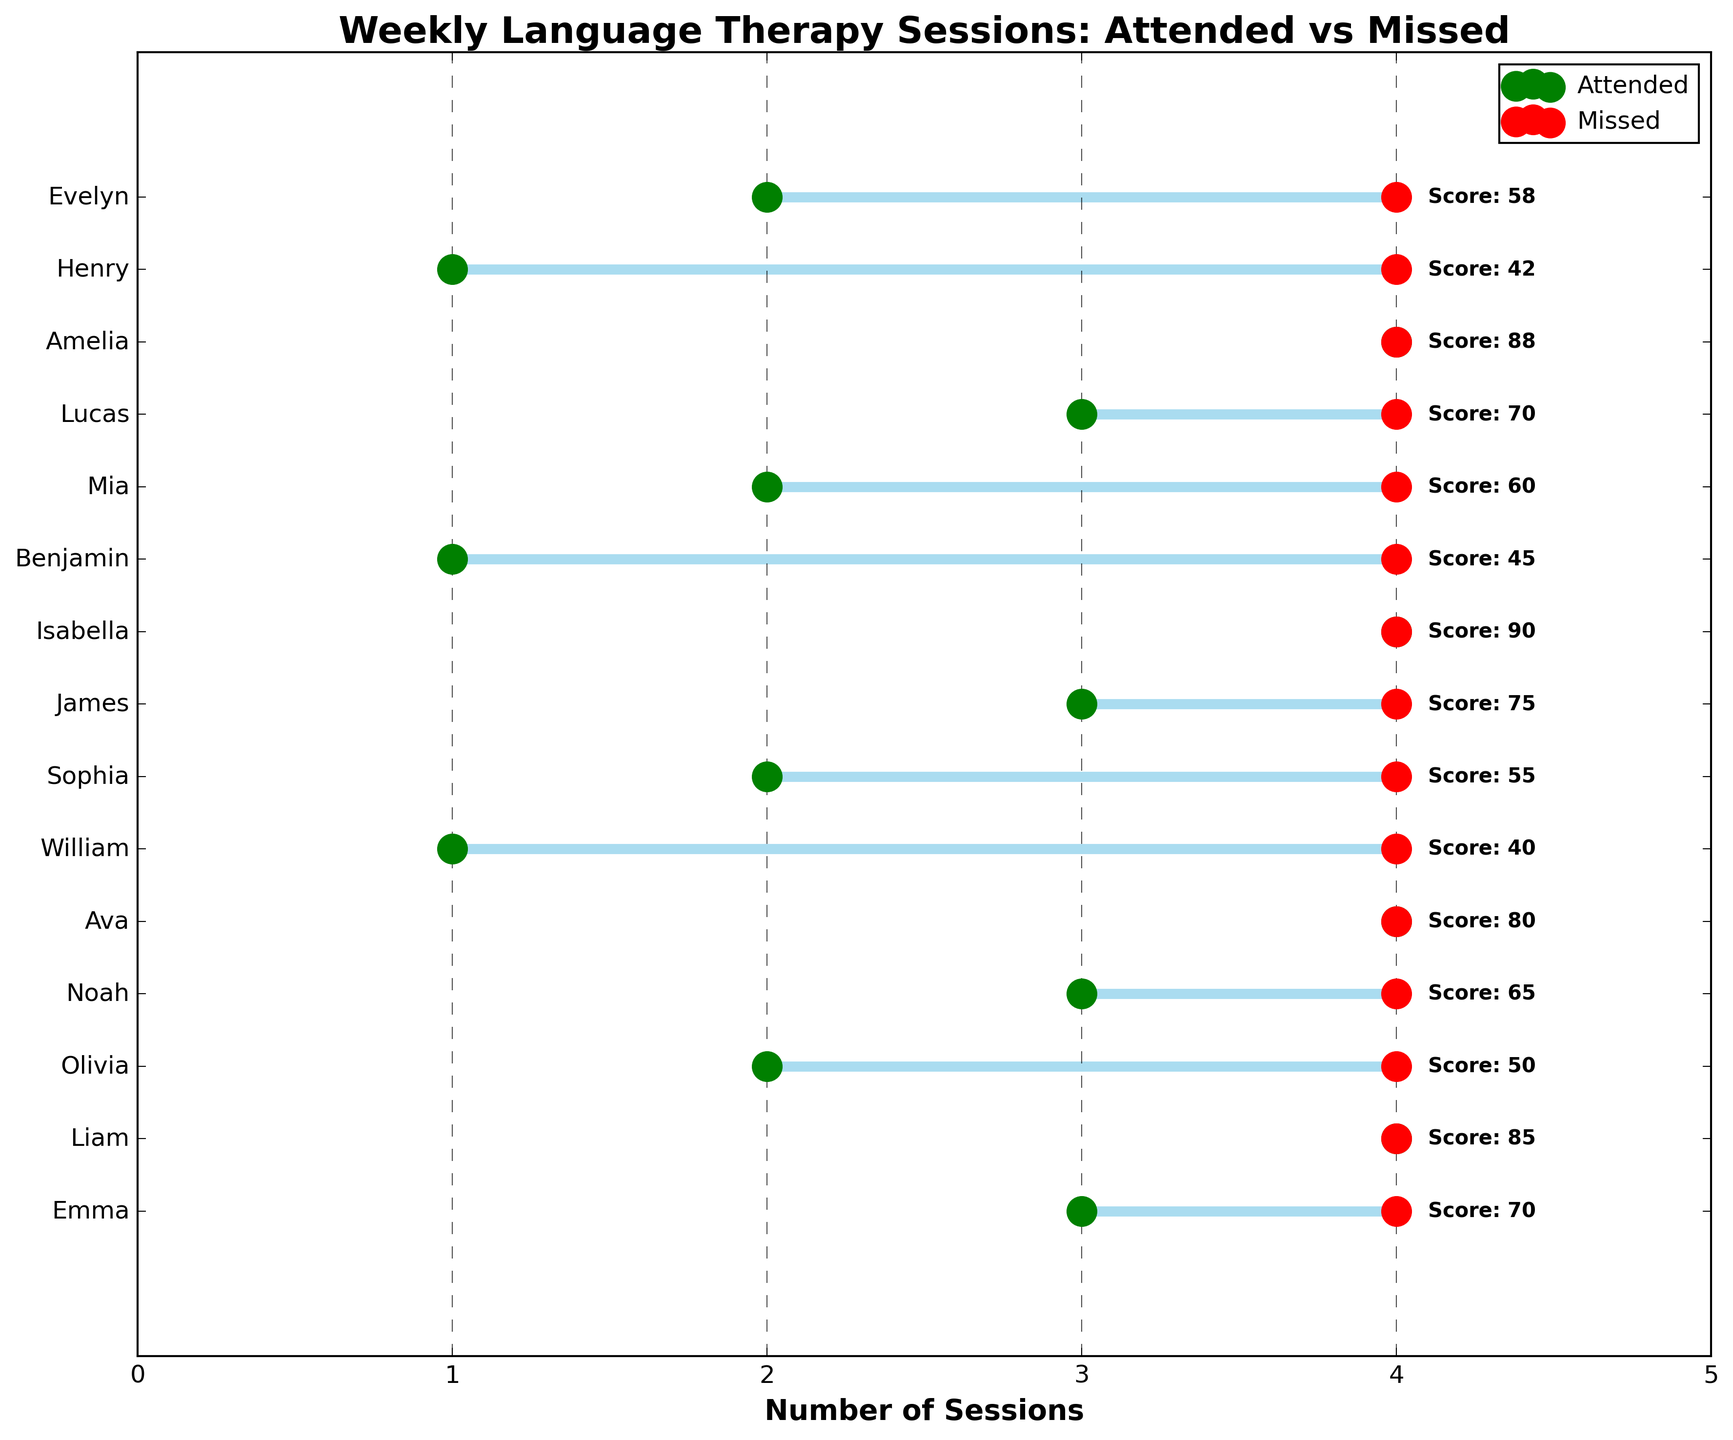What is the title of the figure? The title of the figure is usually located at the top and describes what the plot is about.
Answer: Weekly Language Therapy Sessions: Attended vs Missed How many sessions did Liam attend weekly? Liam's attended sessions can be found by looking at the green dot in his row.
Answer: 4 Whose progress score is the highest? The highest progress score is found next to the child with the highest numerical value indicated beside their name.
Answer: Isabella Which child missed the most number of weekly sessions? The child with the farthest red dot to the right represents the most missed sessions.
Answer: William What is the total number of weekly sessions attended by Emma? Emma's total attended sessions are indicated by the location of her green dot.
Answer: 3 What is the average progress score of the children who attended 4 sessions and missed 0? Look at the progress scores of the children who have green dots at 4 and no red dots, and calculate their average. Olivia: 50, Ava: 80, Isabella: 90, Amelia: 88. Average = (80 + 90 + 88) / 3
Answer: 85.3 Compare the progress score of Emma and William. Whose progress score is higher? Emma's progress score is 70, and William's progress score is 40.
Answer: Emma How many children attended exactly 3 sessions weekly? Count the number of green dots at the position 3 on the x-axis.
Answer: 4 What is the relationship between missed sessions and progress score? Look at the general trend: Higher progress scores seem to be associated with fewer missed sessions.
Answer: More missed sessions generally correlate with lower progress scores Which child has a progress score of 70? Find the child with the progress score of 70 noted beside their name.
Answer: Emma and Lucas 